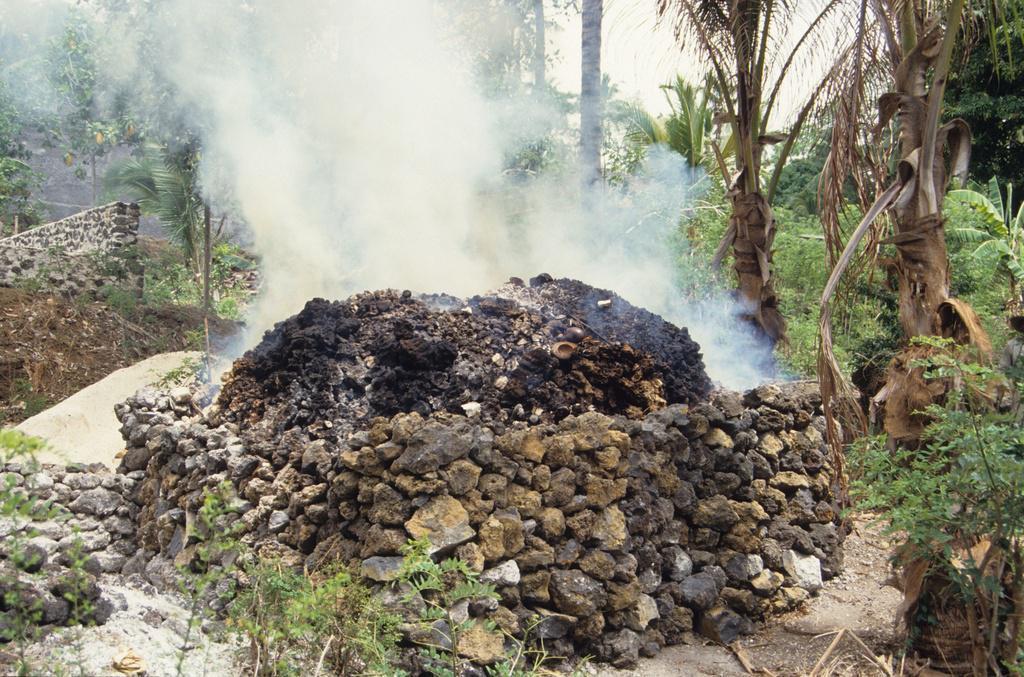Please provide a concise description of this image. In the foreground I can see a stone fence, grass, plants and trees. At the top I can see the sky. This image is taken during a day. 